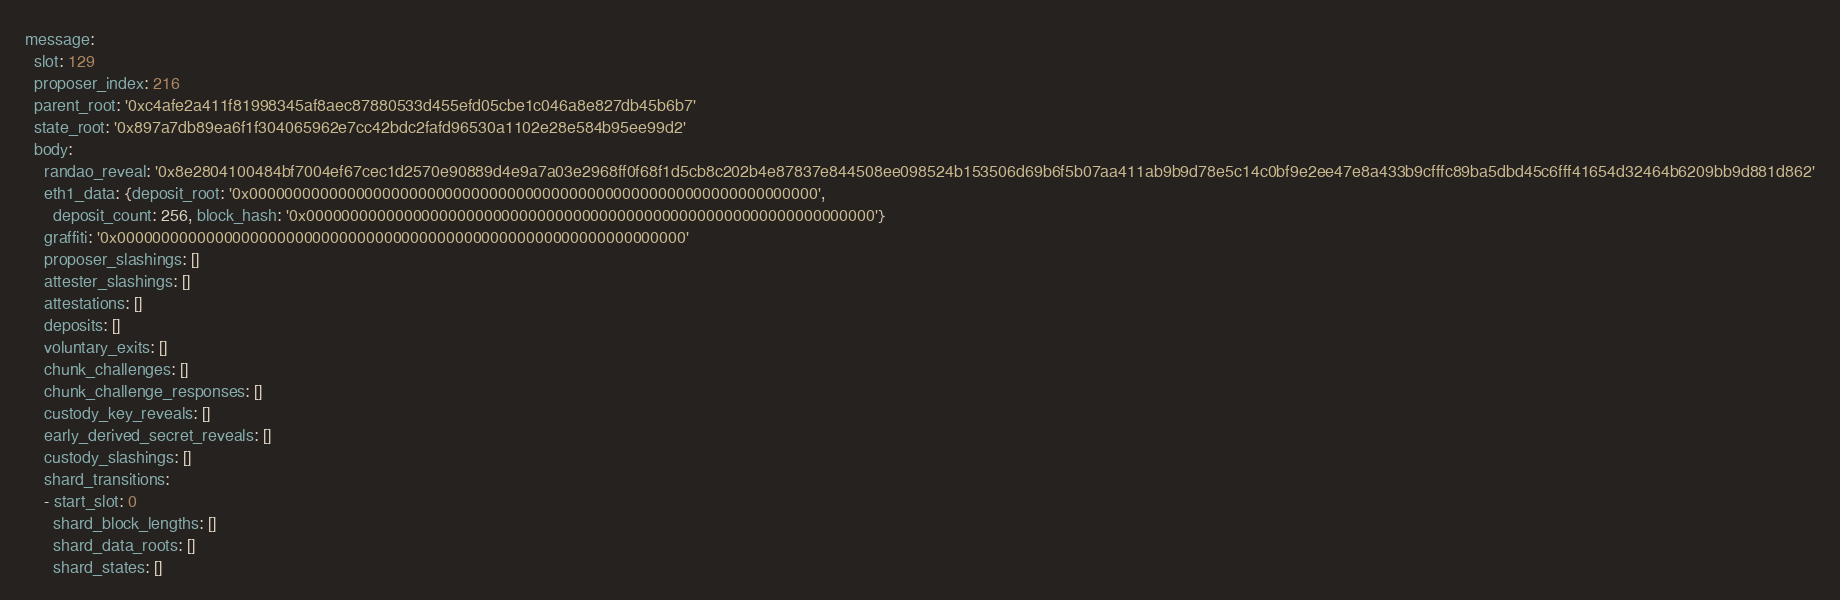<code> <loc_0><loc_0><loc_500><loc_500><_YAML_>message:
  slot: 129
  proposer_index: 216
  parent_root: '0xc4afe2a411f81998345af8aec87880533d455efd05cbe1c046a8e827db45b6b7'
  state_root: '0x897a7db89ea6f1f304065962e7cc42bdc2fafd96530a1102e28e584b95ee99d2'
  body:
    randao_reveal: '0x8e2804100484bf7004ef67cec1d2570e90889d4e9a7a03e2968ff0f68f1d5cb8c202b4e87837e844508ee098524b153506d69b6f5b07aa411ab9b9d78e5c14c0bf9e2ee47e8a433b9cfffc89ba5dbd45c6fff41654d32464b6209bb9d881d862'
    eth1_data: {deposit_root: '0x0000000000000000000000000000000000000000000000000000000000000000',
      deposit_count: 256, block_hash: '0x0000000000000000000000000000000000000000000000000000000000000000'}
    graffiti: '0x0000000000000000000000000000000000000000000000000000000000000000'
    proposer_slashings: []
    attester_slashings: []
    attestations: []
    deposits: []
    voluntary_exits: []
    chunk_challenges: []
    chunk_challenge_responses: []
    custody_key_reveals: []
    early_derived_secret_reveals: []
    custody_slashings: []
    shard_transitions:
    - start_slot: 0
      shard_block_lengths: []
      shard_data_roots: []
      shard_states: []</code> 